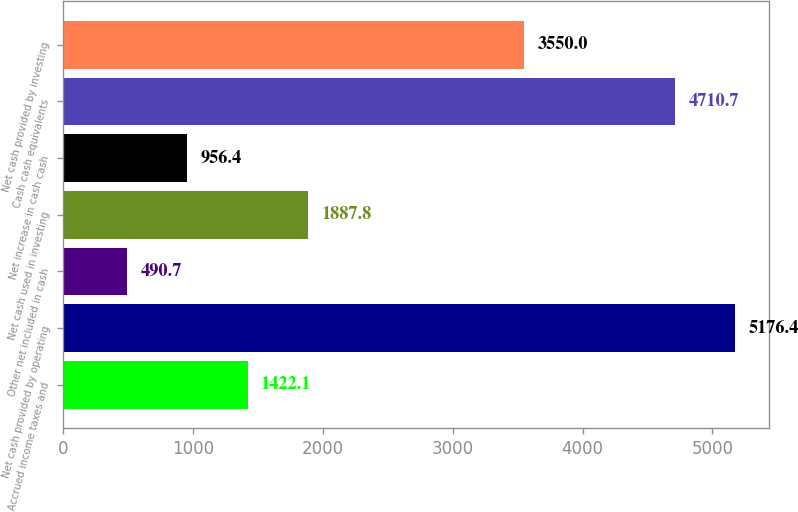Convert chart. <chart><loc_0><loc_0><loc_500><loc_500><bar_chart><fcel>Accrued income taxes and<fcel>Net cash provided by operating<fcel>Other net included in cash<fcel>Net cash used in investing<fcel>Net increase in cash cash<fcel>Cash cash equivalents<fcel>Net cash provided by investing<nl><fcel>1422.1<fcel>5176.4<fcel>490.7<fcel>1887.8<fcel>956.4<fcel>4710.7<fcel>3550<nl></chart> 